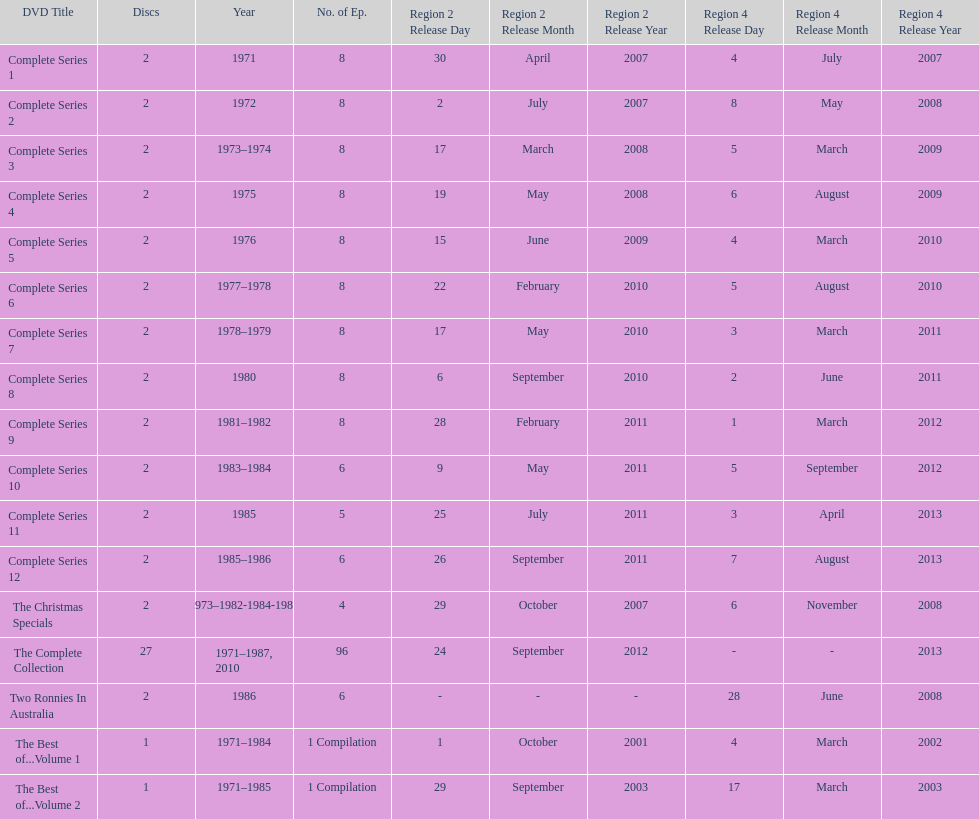What comes immediately after complete series 11? Complete Series 12. 